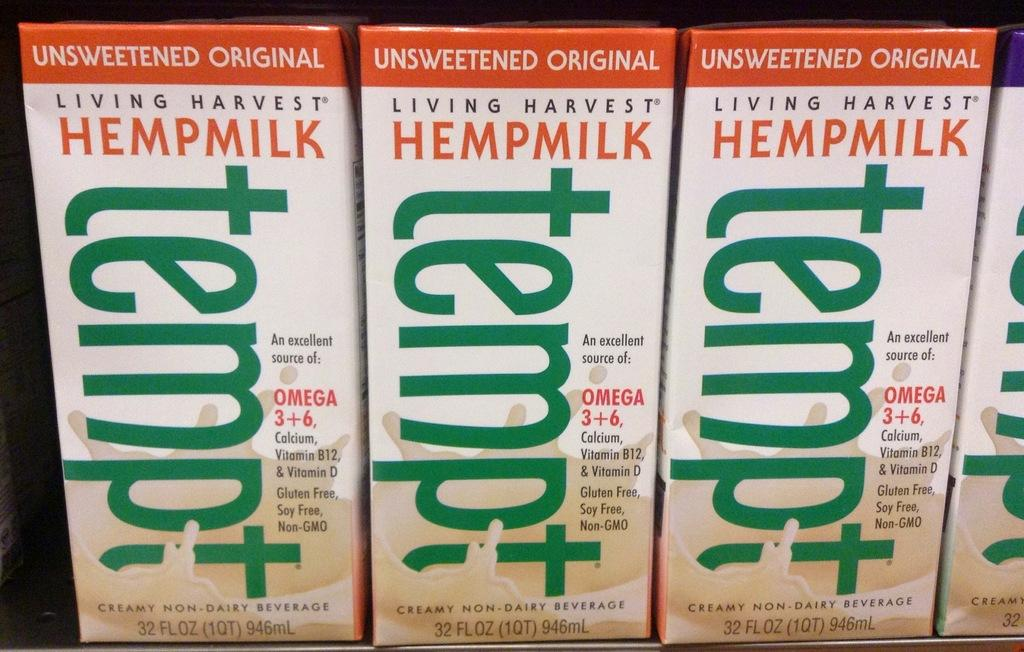<image>
Write a terse but informative summary of the picture. Several cases of Hempmilk that is unsweetened and by the brand known as Tempt.. 